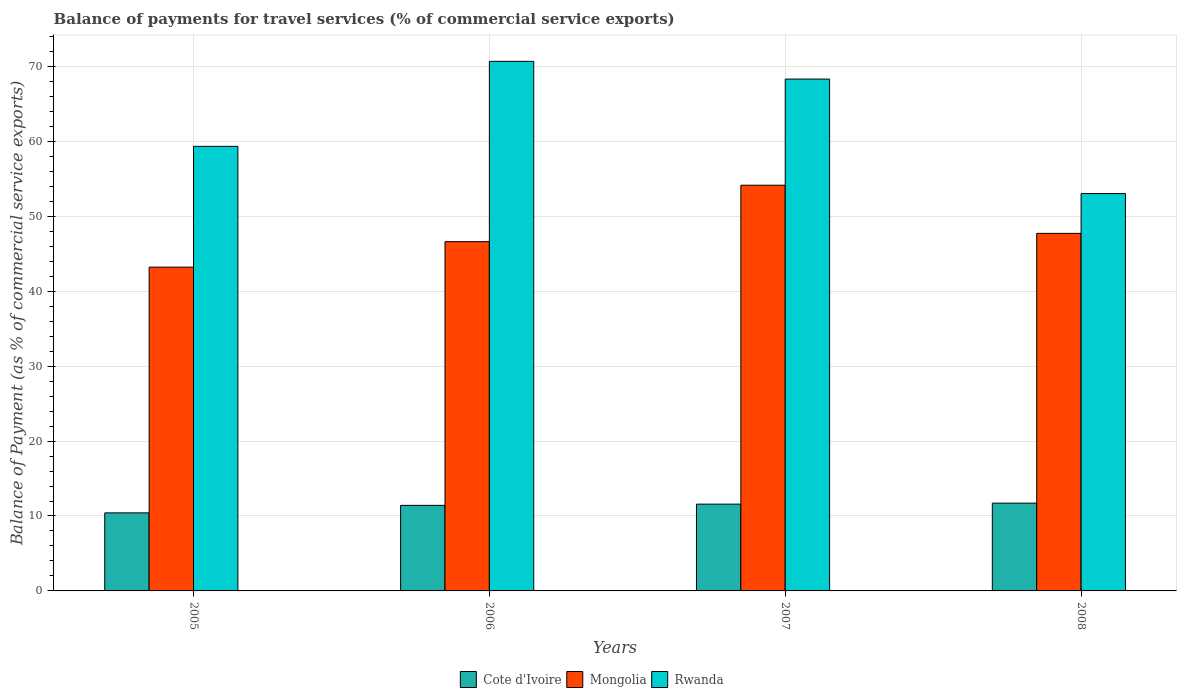How many different coloured bars are there?
Offer a very short reply. 3. How many groups of bars are there?
Your answer should be very brief. 4. What is the label of the 3rd group of bars from the left?
Ensure brevity in your answer.  2007. What is the balance of payments for travel services in Mongolia in 2005?
Offer a very short reply. 43.21. Across all years, what is the maximum balance of payments for travel services in Mongolia?
Provide a short and direct response. 54.14. Across all years, what is the minimum balance of payments for travel services in Cote d'Ivoire?
Ensure brevity in your answer.  10.42. In which year was the balance of payments for travel services in Mongolia maximum?
Your answer should be compact. 2007. In which year was the balance of payments for travel services in Rwanda minimum?
Ensure brevity in your answer.  2008. What is the total balance of payments for travel services in Cote d'Ivoire in the graph?
Offer a terse response. 45.13. What is the difference between the balance of payments for travel services in Cote d'Ivoire in 2007 and that in 2008?
Offer a very short reply. -0.13. What is the difference between the balance of payments for travel services in Cote d'Ivoire in 2007 and the balance of payments for travel services in Mongolia in 2006?
Ensure brevity in your answer.  -35.03. What is the average balance of payments for travel services in Mongolia per year?
Your answer should be compact. 47.92. In the year 2008, what is the difference between the balance of payments for travel services in Mongolia and balance of payments for travel services in Rwanda?
Give a very brief answer. -5.31. What is the ratio of the balance of payments for travel services in Rwanda in 2007 to that in 2008?
Your response must be concise. 1.29. What is the difference between the highest and the second highest balance of payments for travel services in Rwanda?
Make the answer very short. 2.36. What is the difference between the highest and the lowest balance of payments for travel services in Mongolia?
Keep it short and to the point. 10.93. Is the sum of the balance of payments for travel services in Cote d'Ivoire in 2005 and 2008 greater than the maximum balance of payments for travel services in Mongolia across all years?
Provide a short and direct response. No. What does the 3rd bar from the left in 2008 represents?
Give a very brief answer. Rwanda. What does the 1st bar from the right in 2008 represents?
Make the answer very short. Rwanda. Is it the case that in every year, the sum of the balance of payments for travel services in Rwanda and balance of payments for travel services in Cote d'Ivoire is greater than the balance of payments for travel services in Mongolia?
Your response must be concise. Yes. Does the graph contain any zero values?
Your answer should be very brief. No. Does the graph contain grids?
Give a very brief answer. Yes. Where does the legend appear in the graph?
Keep it short and to the point. Bottom center. How are the legend labels stacked?
Ensure brevity in your answer.  Horizontal. What is the title of the graph?
Your answer should be compact. Balance of payments for travel services (% of commercial service exports). What is the label or title of the X-axis?
Keep it short and to the point. Years. What is the label or title of the Y-axis?
Your answer should be compact. Balance of Payment (as % of commercial service exports). What is the Balance of Payment (as % of commercial service exports) of Cote d'Ivoire in 2005?
Provide a short and direct response. 10.42. What is the Balance of Payment (as % of commercial service exports) of Mongolia in 2005?
Your answer should be compact. 43.21. What is the Balance of Payment (as % of commercial service exports) in Rwanda in 2005?
Provide a succinct answer. 59.33. What is the Balance of Payment (as % of commercial service exports) of Cote d'Ivoire in 2006?
Keep it short and to the point. 11.42. What is the Balance of Payment (as % of commercial service exports) in Mongolia in 2006?
Your answer should be compact. 46.61. What is the Balance of Payment (as % of commercial service exports) of Rwanda in 2006?
Provide a succinct answer. 70.67. What is the Balance of Payment (as % of commercial service exports) in Cote d'Ivoire in 2007?
Your response must be concise. 11.58. What is the Balance of Payment (as % of commercial service exports) in Mongolia in 2007?
Give a very brief answer. 54.14. What is the Balance of Payment (as % of commercial service exports) in Rwanda in 2007?
Your answer should be compact. 68.31. What is the Balance of Payment (as % of commercial service exports) in Cote d'Ivoire in 2008?
Your answer should be very brief. 11.72. What is the Balance of Payment (as % of commercial service exports) in Mongolia in 2008?
Make the answer very short. 47.72. What is the Balance of Payment (as % of commercial service exports) in Rwanda in 2008?
Provide a short and direct response. 53.03. Across all years, what is the maximum Balance of Payment (as % of commercial service exports) in Cote d'Ivoire?
Provide a succinct answer. 11.72. Across all years, what is the maximum Balance of Payment (as % of commercial service exports) in Mongolia?
Make the answer very short. 54.14. Across all years, what is the maximum Balance of Payment (as % of commercial service exports) in Rwanda?
Your answer should be very brief. 70.67. Across all years, what is the minimum Balance of Payment (as % of commercial service exports) of Cote d'Ivoire?
Your response must be concise. 10.42. Across all years, what is the minimum Balance of Payment (as % of commercial service exports) of Mongolia?
Your answer should be very brief. 43.21. Across all years, what is the minimum Balance of Payment (as % of commercial service exports) in Rwanda?
Offer a very short reply. 53.03. What is the total Balance of Payment (as % of commercial service exports) of Cote d'Ivoire in the graph?
Provide a succinct answer. 45.13. What is the total Balance of Payment (as % of commercial service exports) in Mongolia in the graph?
Give a very brief answer. 191.69. What is the total Balance of Payment (as % of commercial service exports) in Rwanda in the graph?
Ensure brevity in your answer.  251.34. What is the difference between the Balance of Payment (as % of commercial service exports) in Cote d'Ivoire in 2005 and that in 2006?
Your response must be concise. -1. What is the difference between the Balance of Payment (as % of commercial service exports) of Mongolia in 2005 and that in 2006?
Make the answer very short. -3.4. What is the difference between the Balance of Payment (as % of commercial service exports) in Rwanda in 2005 and that in 2006?
Offer a very short reply. -11.34. What is the difference between the Balance of Payment (as % of commercial service exports) of Cote d'Ivoire in 2005 and that in 2007?
Your answer should be very brief. -1.16. What is the difference between the Balance of Payment (as % of commercial service exports) in Mongolia in 2005 and that in 2007?
Give a very brief answer. -10.93. What is the difference between the Balance of Payment (as % of commercial service exports) of Rwanda in 2005 and that in 2007?
Offer a terse response. -8.98. What is the difference between the Balance of Payment (as % of commercial service exports) in Cote d'Ivoire in 2005 and that in 2008?
Offer a terse response. -1.3. What is the difference between the Balance of Payment (as % of commercial service exports) in Mongolia in 2005 and that in 2008?
Make the answer very short. -4.5. What is the difference between the Balance of Payment (as % of commercial service exports) in Rwanda in 2005 and that in 2008?
Make the answer very short. 6.3. What is the difference between the Balance of Payment (as % of commercial service exports) in Cote d'Ivoire in 2006 and that in 2007?
Keep it short and to the point. -0.17. What is the difference between the Balance of Payment (as % of commercial service exports) in Mongolia in 2006 and that in 2007?
Keep it short and to the point. -7.53. What is the difference between the Balance of Payment (as % of commercial service exports) of Rwanda in 2006 and that in 2007?
Ensure brevity in your answer.  2.37. What is the difference between the Balance of Payment (as % of commercial service exports) of Cote d'Ivoire in 2006 and that in 2008?
Provide a short and direct response. -0.3. What is the difference between the Balance of Payment (as % of commercial service exports) of Mongolia in 2006 and that in 2008?
Keep it short and to the point. -1.1. What is the difference between the Balance of Payment (as % of commercial service exports) in Rwanda in 2006 and that in 2008?
Make the answer very short. 17.64. What is the difference between the Balance of Payment (as % of commercial service exports) of Cote d'Ivoire in 2007 and that in 2008?
Offer a terse response. -0.13. What is the difference between the Balance of Payment (as % of commercial service exports) of Mongolia in 2007 and that in 2008?
Your response must be concise. 6.43. What is the difference between the Balance of Payment (as % of commercial service exports) of Rwanda in 2007 and that in 2008?
Provide a succinct answer. 15.28. What is the difference between the Balance of Payment (as % of commercial service exports) in Cote d'Ivoire in 2005 and the Balance of Payment (as % of commercial service exports) in Mongolia in 2006?
Offer a terse response. -36.2. What is the difference between the Balance of Payment (as % of commercial service exports) in Cote d'Ivoire in 2005 and the Balance of Payment (as % of commercial service exports) in Rwanda in 2006?
Keep it short and to the point. -60.26. What is the difference between the Balance of Payment (as % of commercial service exports) in Mongolia in 2005 and the Balance of Payment (as % of commercial service exports) in Rwanda in 2006?
Your answer should be compact. -27.46. What is the difference between the Balance of Payment (as % of commercial service exports) of Cote d'Ivoire in 2005 and the Balance of Payment (as % of commercial service exports) of Mongolia in 2007?
Provide a short and direct response. -43.73. What is the difference between the Balance of Payment (as % of commercial service exports) of Cote d'Ivoire in 2005 and the Balance of Payment (as % of commercial service exports) of Rwanda in 2007?
Keep it short and to the point. -57.89. What is the difference between the Balance of Payment (as % of commercial service exports) in Mongolia in 2005 and the Balance of Payment (as % of commercial service exports) in Rwanda in 2007?
Provide a succinct answer. -25.1. What is the difference between the Balance of Payment (as % of commercial service exports) in Cote d'Ivoire in 2005 and the Balance of Payment (as % of commercial service exports) in Mongolia in 2008?
Provide a short and direct response. -37.3. What is the difference between the Balance of Payment (as % of commercial service exports) of Cote d'Ivoire in 2005 and the Balance of Payment (as % of commercial service exports) of Rwanda in 2008?
Make the answer very short. -42.61. What is the difference between the Balance of Payment (as % of commercial service exports) of Mongolia in 2005 and the Balance of Payment (as % of commercial service exports) of Rwanda in 2008?
Provide a short and direct response. -9.82. What is the difference between the Balance of Payment (as % of commercial service exports) of Cote d'Ivoire in 2006 and the Balance of Payment (as % of commercial service exports) of Mongolia in 2007?
Provide a succinct answer. -42.73. What is the difference between the Balance of Payment (as % of commercial service exports) of Cote d'Ivoire in 2006 and the Balance of Payment (as % of commercial service exports) of Rwanda in 2007?
Your answer should be compact. -56.89. What is the difference between the Balance of Payment (as % of commercial service exports) in Mongolia in 2006 and the Balance of Payment (as % of commercial service exports) in Rwanda in 2007?
Provide a succinct answer. -21.7. What is the difference between the Balance of Payment (as % of commercial service exports) in Cote d'Ivoire in 2006 and the Balance of Payment (as % of commercial service exports) in Mongolia in 2008?
Give a very brief answer. -36.3. What is the difference between the Balance of Payment (as % of commercial service exports) in Cote d'Ivoire in 2006 and the Balance of Payment (as % of commercial service exports) in Rwanda in 2008?
Offer a very short reply. -41.61. What is the difference between the Balance of Payment (as % of commercial service exports) in Mongolia in 2006 and the Balance of Payment (as % of commercial service exports) in Rwanda in 2008?
Provide a short and direct response. -6.42. What is the difference between the Balance of Payment (as % of commercial service exports) in Cote d'Ivoire in 2007 and the Balance of Payment (as % of commercial service exports) in Mongolia in 2008?
Offer a terse response. -36.13. What is the difference between the Balance of Payment (as % of commercial service exports) in Cote d'Ivoire in 2007 and the Balance of Payment (as % of commercial service exports) in Rwanda in 2008?
Keep it short and to the point. -41.45. What is the difference between the Balance of Payment (as % of commercial service exports) in Mongolia in 2007 and the Balance of Payment (as % of commercial service exports) in Rwanda in 2008?
Offer a very short reply. 1.12. What is the average Balance of Payment (as % of commercial service exports) of Cote d'Ivoire per year?
Provide a short and direct response. 11.28. What is the average Balance of Payment (as % of commercial service exports) of Mongolia per year?
Offer a very short reply. 47.92. What is the average Balance of Payment (as % of commercial service exports) in Rwanda per year?
Offer a very short reply. 62.84. In the year 2005, what is the difference between the Balance of Payment (as % of commercial service exports) of Cote d'Ivoire and Balance of Payment (as % of commercial service exports) of Mongolia?
Provide a succinct answer. -32.79. In the year 2005, what is the difference between the Balance of Payment (as % of commercial service exports) in Cote d'Ivoire and Balance of Payment (as % of commercial service exports) in Rwanda?
Your response must be concise. -48.91. In the year 2005, what is the difference between the Balance of Payment (as % of commercial service exports) of Mongolia and Balance of Payment (as % of commercial service exports) of Rwanda?
Make the answer very short. -16.12. In the year 2006, what is the difference between the Balance of Payment (as % of commercial service exports) of Cote d'Ivoire and Balance of Payment (as % of commercial service exports) of Mongolia?
Offer a terse response. -35.2. In the year 2006, what is the difference between the Balance of Payment (as % of commercial service exports) of Cote d'Ivoire and Balance of Payment (as % of commercial service exports) of Rwanda?
Give a very brief answer. -59.26. In the year 2006, what is the difference between the Balance of Payment (as % of commercial service exports) of Mongolia and Balance of Payment (as % of commercial service exports) of Rwanda?
Your answer should be compact. -24.06. In the year 2007, what is the difference between the Balance of Payment (as % of commercial service exports) of Cote d'Ivoire and Balance of Payment (as % of commercial service exports) of Mongolia?
Offer a terse response. -42.56. In the year 2007, what is the difference between the Balance of Payment (as % of commercial service exports) of Cote d'Ivoire and Balance of Payment (as % of commercial service exports) of Rwanda?
Provide a succinct answer. -56.73. In the year 2007, what is the difference between the Balance of Payment (as % of commercial service exports) of Mongolia and Balance of Payment (as % of commercial service exports) of Rwanda?
Make the answer very short. -14.16. In the year 2008, what is the difference between the Balance of Payment (as % of commercial service exports) in Cote d'Ivoire and Balance of Payment (as % of commercial service exports) in Mongolia?
Give a very brief answer. -36. In the year 2008, what is the difference between the Balance of Payment (as % of commercial service exports) in Cote d'Ivoire and Balance of Payment (as % of commercial service exports) in Rwanda?
Offer a very short reply. -41.31. In the year 2008, what is the difference between the Balance of Payment (as % of commercial service exports) in Mongolia and Balance of Payment (as % of commercial service exports) in Rwanda?
Your answer should be very brief. -5.31. What is the ratio of the Balance of Payment (as % of commercial service exports) of Cote d'Ivoire in 2005 to that in 2006?
Provide a short and direct response. 0.91. What is the ratio of the Balance of Payment (as % of commercial service exports) in Mongolia in 2005 to that in 2006?
Your answer should be very brief. 0.93. What is the ratio of the Balance of Payment (as % of commercial service exports) of Rwanda in 2005 to that in 2006?
Keep it short and to the point. 0.84. What is the ratio of the Balance of Payment (as % of commercial service exports) in Cote d'Ivoire in 2005 to that in 2007?
Give a very brief answer. 0.9. What is the ratio of the Balance of Payment (as % of commercial service exports) in Mongolia in 2005 to that in 2007?
Offer a very short reply. 0.8. What is the ratio of the Balance of Payment (as % of commercial service exports) in Rwanda in 2005 to that in 2007?
Keep it short and to the point. 0.87. What is the ratio of the Balance of Payment (as % of commercial service exports) of Cote d'Ivoire in 2005 to that in 2008?
Your answer should be very brief. 0.89. What is the ratio of the Balance of Payment (as % of commercial service exports) in Mongolia in 2005 to that in 2008?
Ensure brevity in your answer.  0.91. What is the ratio of the Balance of Payment (as % of commercial service exports) of Rwanda in 2005 to that in 2008?
Provide a succinct answer. 1.12. What is the ratio of the Balance of Payment (as % of commercial service exports) of Cote d'Ivoire in 2006 to that in 2007?
Your answer should be very brief. 0.99. What is the ratio of the Balance of Payment (as % of commercial service exports) in Mongolia in 2006 to that in 2007?
Offer a very short reply. 0.86. What is the ratio of the Balance of Payment (as % of commercial service exports) of Rwanda in 2006 to that in 2007?
Your answer should be compact. 1.03. What is the ratio of the Balance of Payment (as % of commercial service exports) of Cote d'Ivoire in 2006 to that in 2008?
Give a very brief answer. 0.97. What is the ratio of the Balance of Payment (as % of commercial service exports) in Mongolia in 2006 to that in 2008?
Provide a succinct answer. 0.98. What is the ratio of the Balance of Payment (as % of commercial service exports) of Rwanda in 2006 to that in 2008?
Ensure brevity in your answer.  1.33. What is the ratio of the Balance of Payment (as % of commercial service exports) in Mongolia in 2007 to that in 2008?
Your answer should be compact. 1.13. What is the ratio of the Balance of Payment (as % of commercial service exports) of Rwanda in 2007 to that in 2008?
Your answer should be compact. 1.29. What is the difference between the highest and the second highest Balance of Payment (as % of commercial service exports) of Cote d'Ivoire?
Provide a short and direct response. 0.13. What is the difference between the highest and the second highest Balance of Payment (as % of commercial service exports) in Mongolia?
Ensure brevity in your answer.  6.43. What is the difference between the highest and the second highest Balance of Payment (as % of commercial service exports) of Rwanda?
Provide a short and direct response. 2.37. What is the difference between the highest and the lowest Balance of Payment (as % of commercial service exports) of Cote d'Ivoire?
Provide a short and direct response. 1.3. What is the difference between the highest and the lowest Balance of Payment (as % of commercial service exports) of Mongolia?
Keep it short and to the point. 10.93. What is the difference between the highest and the lowest Balance of Payment (as % of commercial service exports) of Rwanda?
Ensure brevity in your answer.  17.64. 